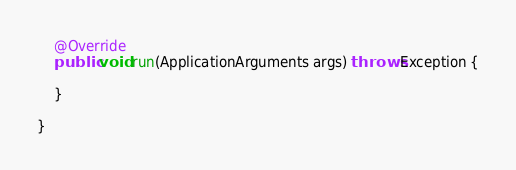<code> <loc_0><loc_0><loc_500><loc_500><_Java_>	@Override
	public void run(ApplicationArguments args) throws Exception {

	}

}
</code> 